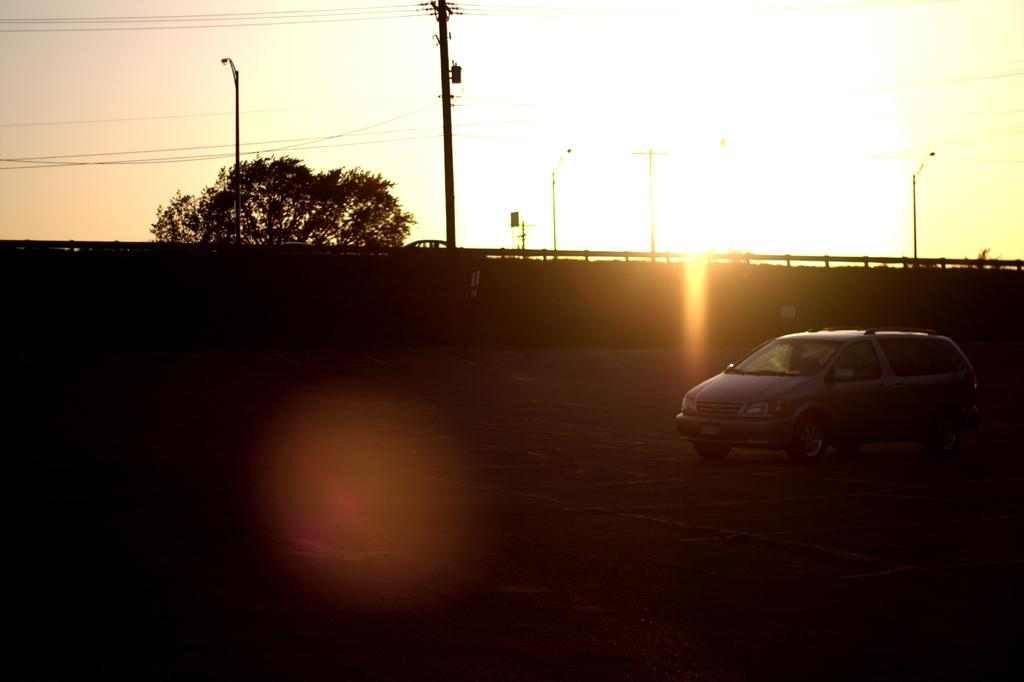What is on the road in the image? There is a vehicle on the road in the image. What can be seen in the background of the image? There is a wall visible in the image. What type of vegetation is present in the image? There is a tree in the image. What type of cushion is being discussed in the image? There is no cushion or discussion present in the image. 